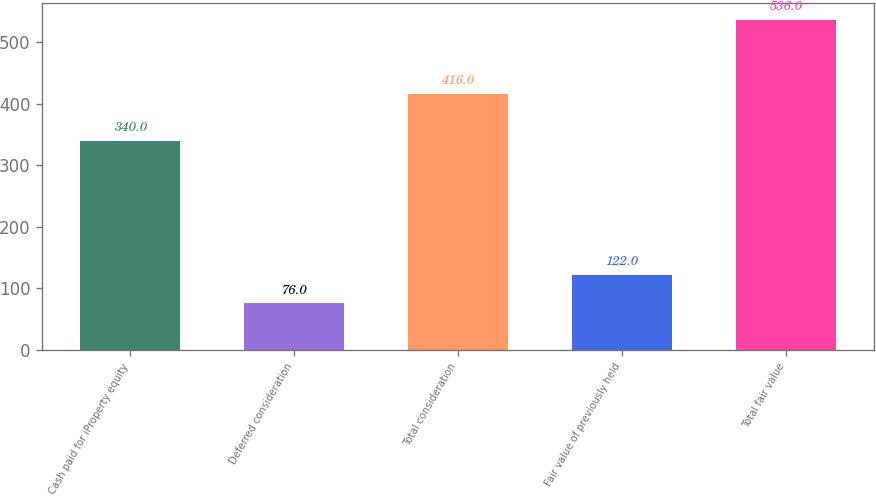Convert chart to OTSL. <chart><loc_0><loc_0><loc_500><loc_500><bar_chart><fcel>Cash paid for iProperty equity<fcel>Deferred consideration<fcel>Total consideration<fcel>Fair value of previously held<fcel>Total fair value<nl><fcel>340<fcel>76<fcel>416<fcel>122<fcel>536<nl></chart> 